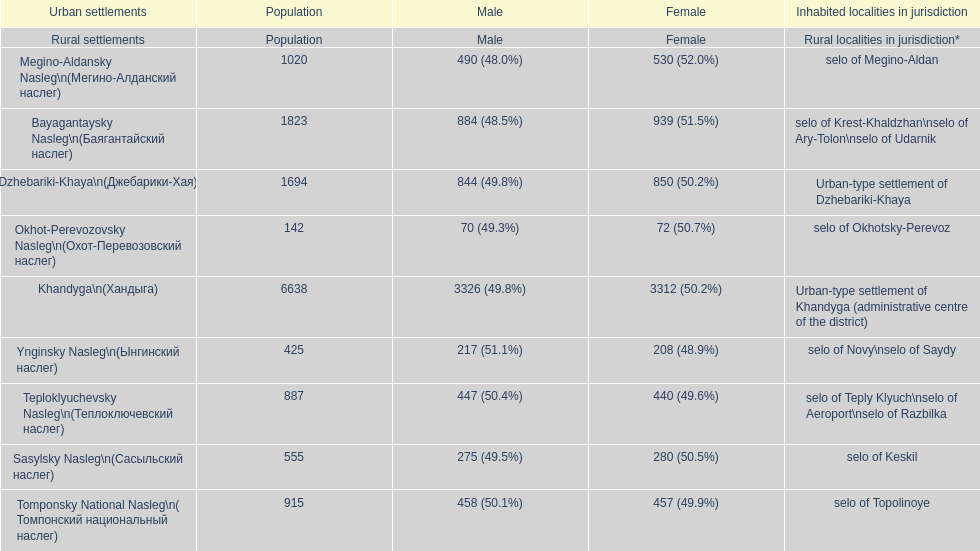How many cities are below 1000 in population? 5. 